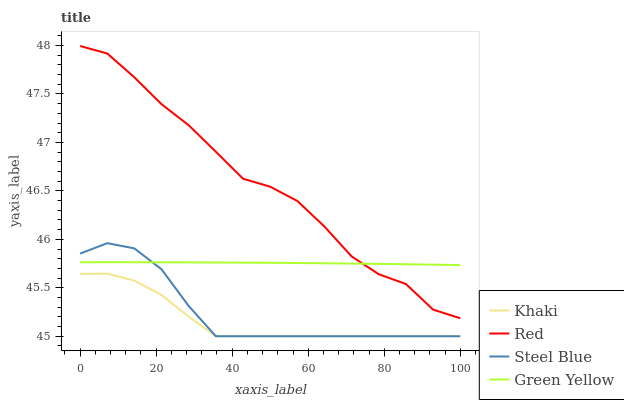Does Khaki have the minimum area under the curve?
Answer yes or no. Yes. Does Red have the maximum area under the curve?
Answer yes or no. Yes. Does Steel Blue have the minimum area under the curve?
Answer yes or no. No. Does Steel Blue have the maximum area under the curve?
Answer yes or no. No. Is Green Yellow the smoothest?
Answer yes or no. Yes. Is Red the roughest?
Answer yes or no. Yes. Is Khaki the smoothest?
Answer yes or no. No. Is Khaki the roughest?
Answer yes or no. No. Does Khaki have the lowest value?
Answer yes or no. Yes. Does Red have the lowest value?
Answer yes or no. No. Does Red have the highest value?
Answer yes or no. Yes. Does Steel Blue have the highest value?
Answer yes or no. No. Is Steel Blue less than Red?
Answer yes or no. Yes. Is Red greater than Steel Blue?
Answer yes or no. Yes. Does Green Yellow intersect Red?
Answer yes or no. Yes. Is Green Yellow less than Red?
Answer yes or no. No. Is Green Yellow greater than Red?
Answer yes or no. No. Does Steel Blue intersect Red?
Answer yes or no. No. 